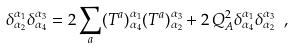Convert formula to latex. <formula><loc_0><loc_0><loc_500><loc_500>\delta ^ { { \alpha } _ { 1 } } _ { \alpha _ { 2 } } \delta ^ { \alpha _ { 3 } } _ { \alpha _ { 4 } } = 2 \sum _ { a } ( T ^ { a } ) ^ { \alpha _ { 1 } } _ { \alpha _ { 4 } } ( T ^ { a } ) ^ { \alpha _ { 3 } } _ { \alpha _ { 2 } } + 2 \, Q ^ { 2 } _ { A } \delta ^ { \alpha _ { 1 } } _ { \alpha _ { 4 } } \delta ^ { \alpha _ { 3 } } _ { \alpha _ { 2 } } \ ,</formula> 